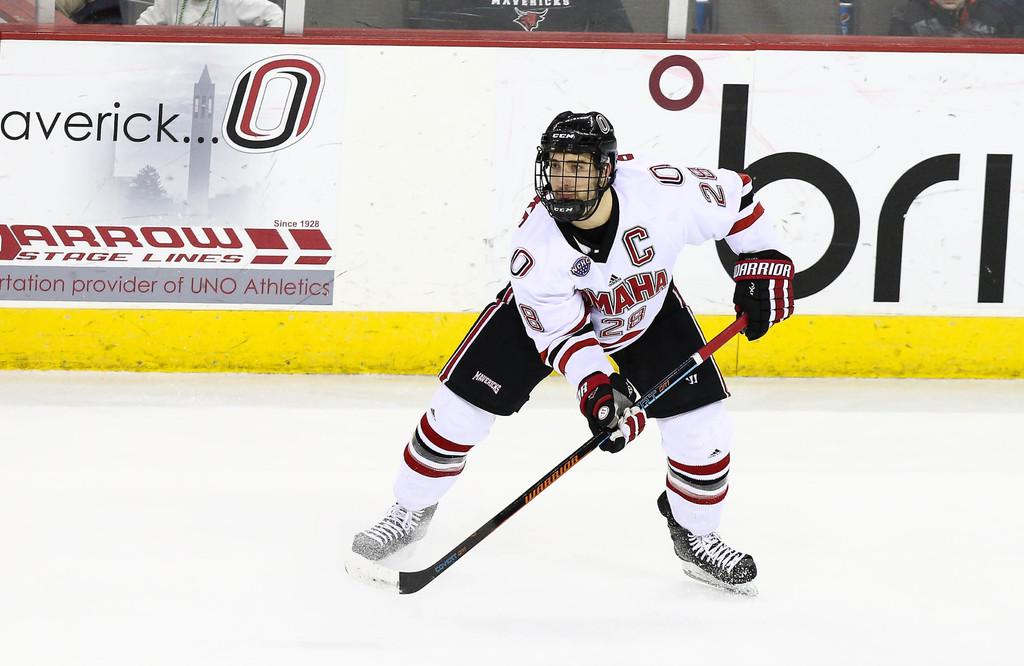<image>
Present a compact description of the photo's key features. Player holding a hockey stick in front of a giant number 0. 